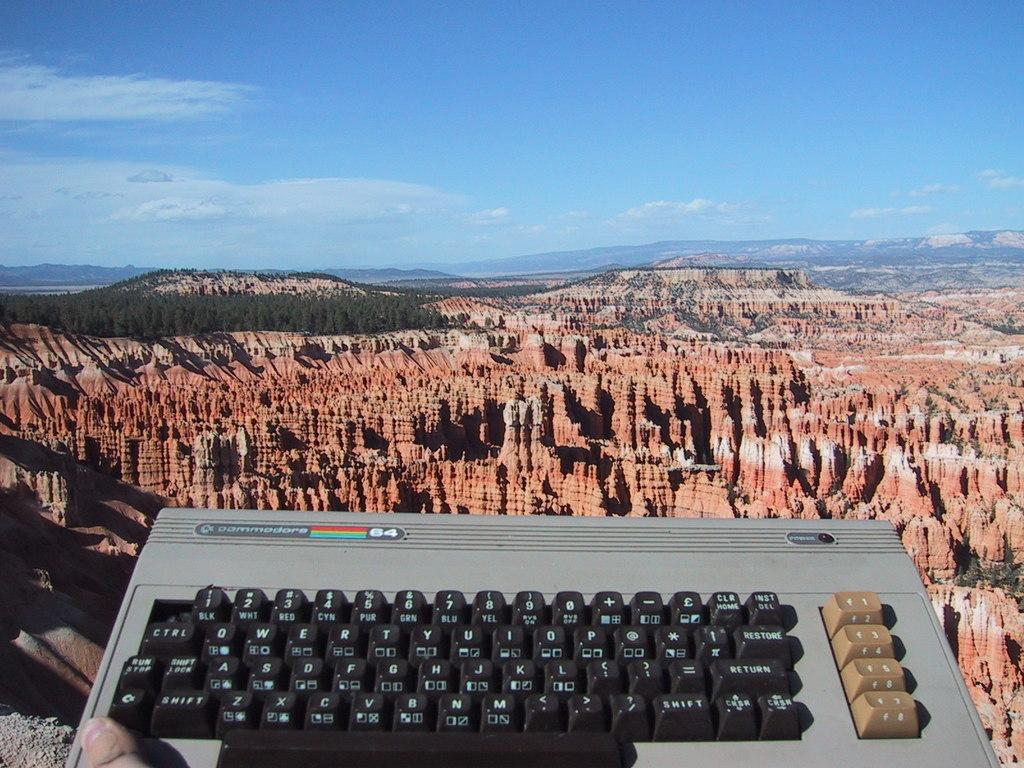<image>
Render a clear and concise summary of the photo. a keyboard for Commodore 64 in front of a natural canyon 